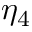Convert formula to latex. <formula><loc_0><loc_0><loc_500><loc_500>\eta _ { 4 }</formula> 